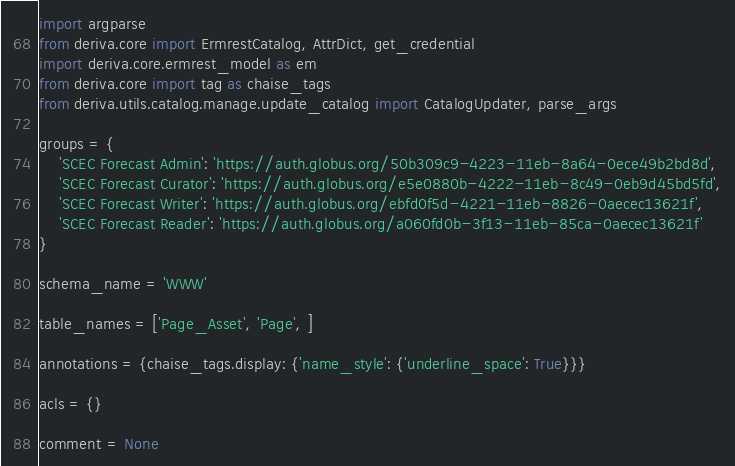<code> <loc_0><loc_0><loc_500><loc_500><_Python_>import argparse
from deriva.core import ErmrestCatalog, AttrDict, get_credential
import deriva.core.ermrest_model as em
from deriva.core import tag as chaise_tags
from deriva.utils.catalog.manage.update_catalog import CatalogUpdater, parse_args

groups = {
    'SCEC Forecast Admin': 'https://auth.globus.org/50b309c9-4223-11eb-8a64-0ece49b2bd8d',
    'SCEC Forecast Curator': 'https://auth.globus.org/e5e0880b-4222-11eb-8c49-0eb9d45bd5fd',
    'SCEC Forecast Writer': 'https://auth.globus.org/ebfd0f5d-4221-11eb-8826-0aecec13621f',
    'SCEC Forecast Reader': 'https://auth.globus.org/a060fd0b-3f13-11eb-85ca-0aecec13621f'
}

schema_name = 'WWW'

table_names = ['Page_Asset', 'Page', ]

annotations = {chaise_tags.display: {'name_style': {'underline_space': True}}}

acls = {}

comment = None
</code> 